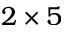Convert formula to latex. <formula><loc_0><loc_0><loc_500><loc_500>2 \times 5</formula> 